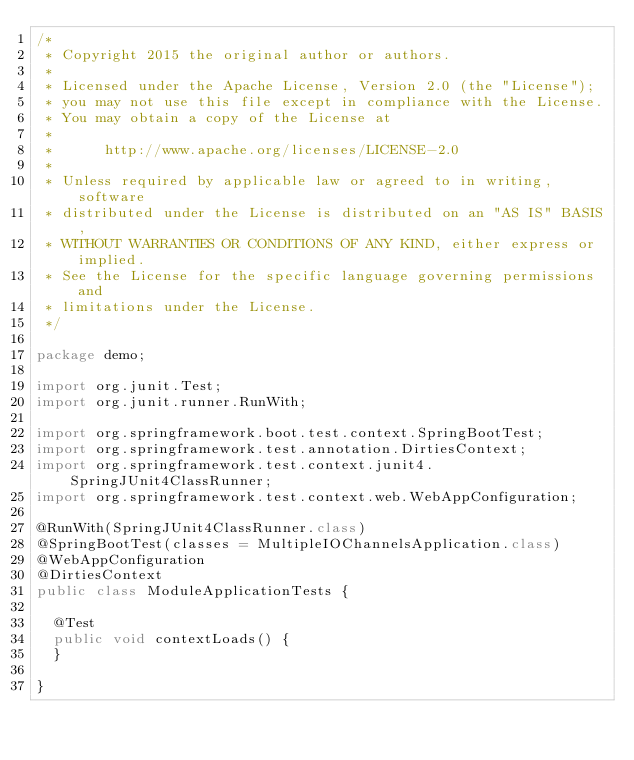Convert code to text. <code><loc_0><loc_0><loc_500><loc_500><_Java_>/*
 * Copyright 2015 the original author or authors.
 *
 * Licensed under the Apache License, Version 2.0 (the "License");
 * you may not use this file except in compliance with the License.
 * You may obtain a copy of the License at
 *
 *      http://www.apache.org/licenses/LICENSE-2.0
 *
 * Unless required by applicable law or agreed to in writing, software
 * distributed under the License is distributed on an "AS IS" BASIS,
 * WITHOUT WARRANTIES OR CONDITIONS OF ANY KIND, either express or implied.
 * See the License for the specific language governing permissions and
 * limitations under the License.
 */

package demo;

import org.junit.Test;
import org.junit.runner.RunWith;

import org.springframework.boot.test.context.SpringBootTest;
import org.springframework.test.annotation.DirtiesContext;
import org.springframework.test.context.junit4.SpringJUnit4ClassRunner;
import org.springframework.test.context.web.WebAppConfiguration;

@RunWith(SpringJUnit4ClassRunner.class)
@SpringBootTest(classes = MultipleIOChannelsApplication.class)
@WebAppConfiguration
@DirtiesContext
public class ModuleApplicationTests {

	@Test
	public void contextLoads() {
	}

}
</code> 